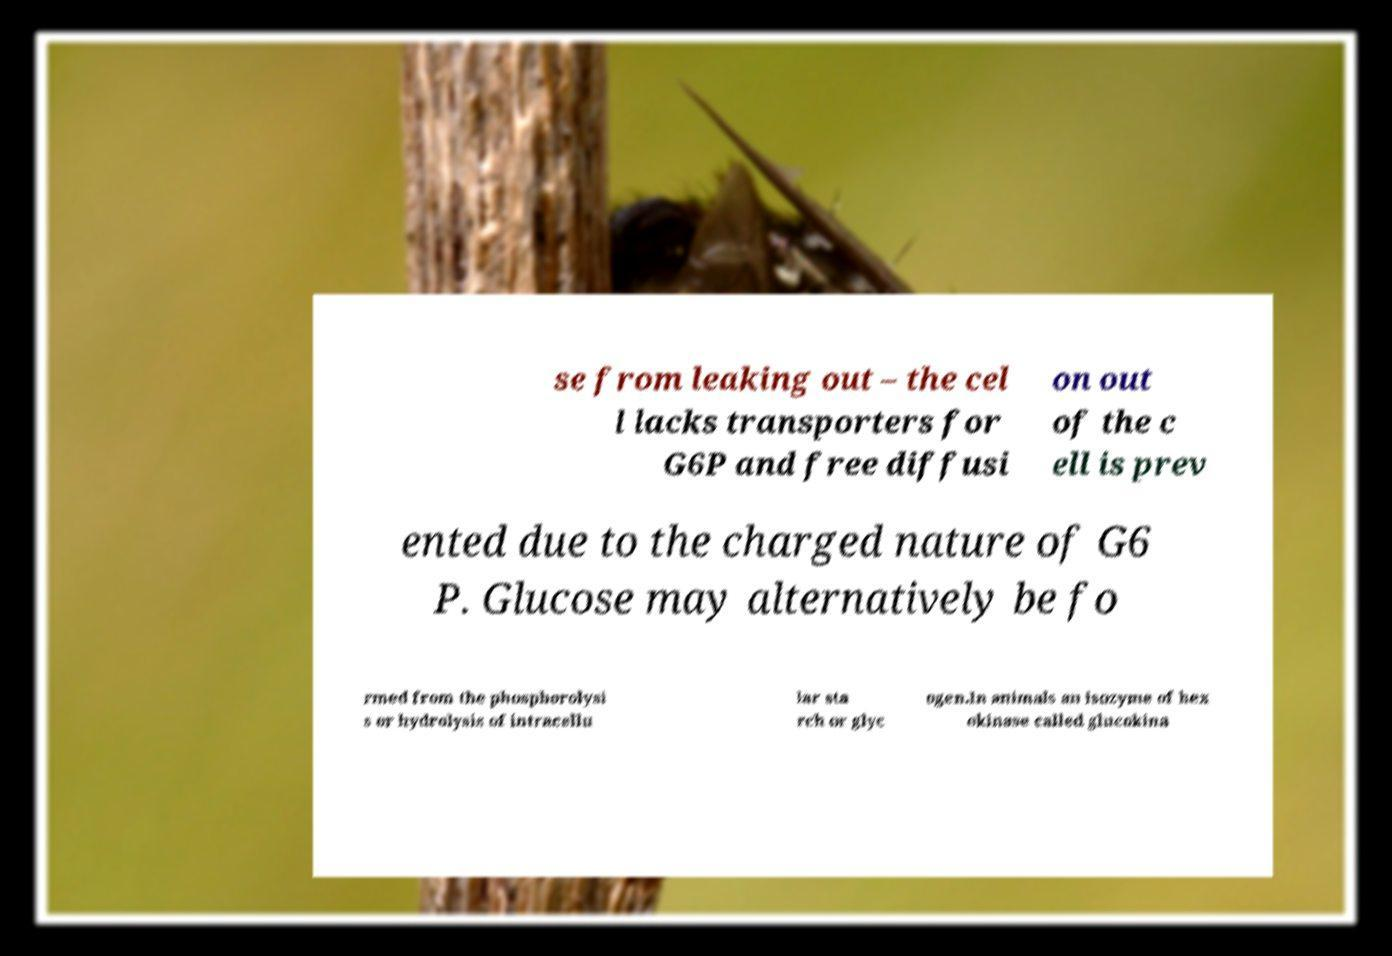Please read and relay the text visible in this image. What does it say? se from leaking out – the cel l lacks transporters for G6P and free diffusi on out of the c ell is prev ented due to the charged nature of G6 P. Glucose may alternatively be fo rmed from the phosphorolysi s or hydrolysis of intracellu lar sta rch or glyc ogen.In animals an isozyme of hex okinase called glucokina 